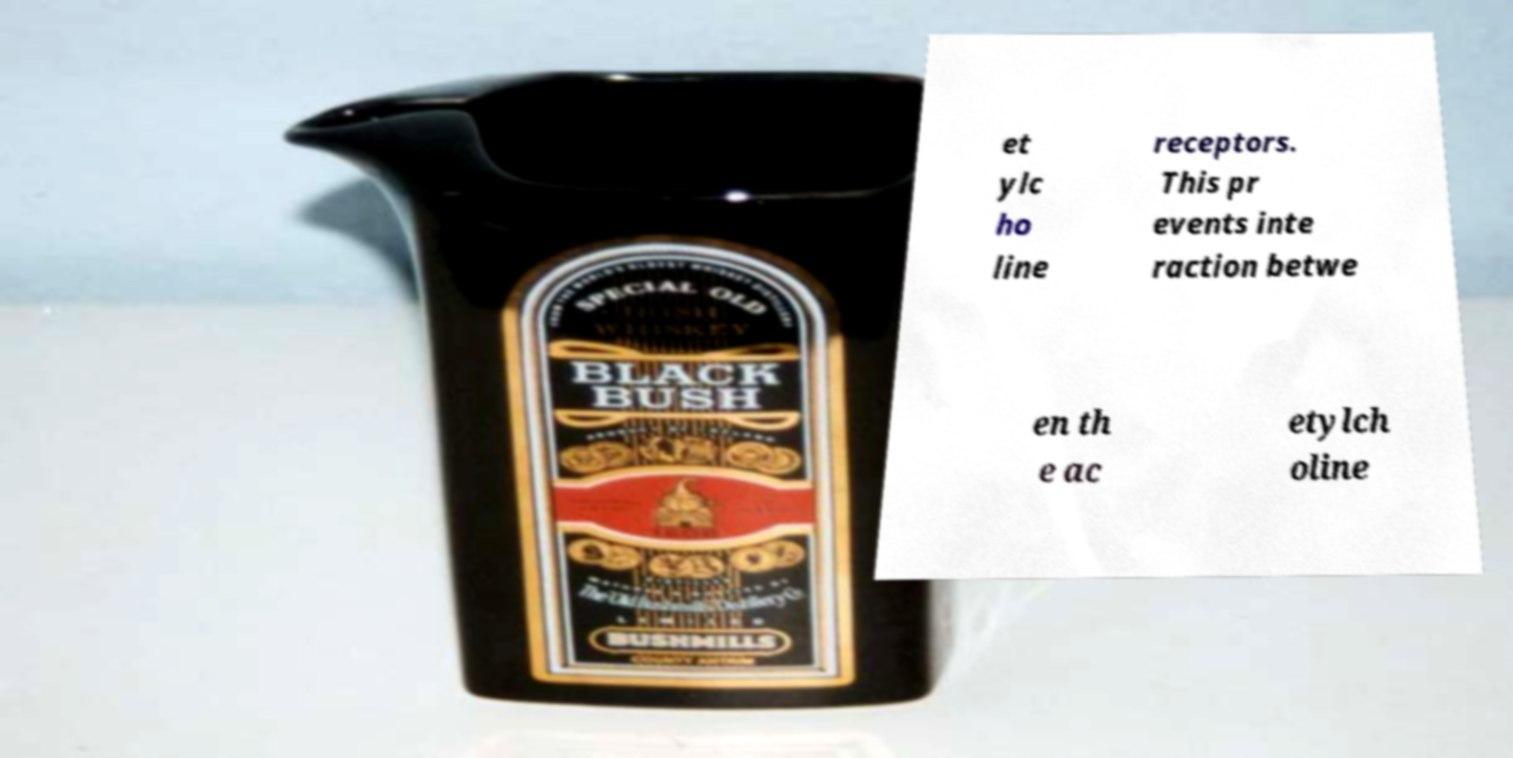Please identify and transcribe the text found in this image. et ylc ho line receptors. This pr events inte raction betwe en th e ac etylch oline 